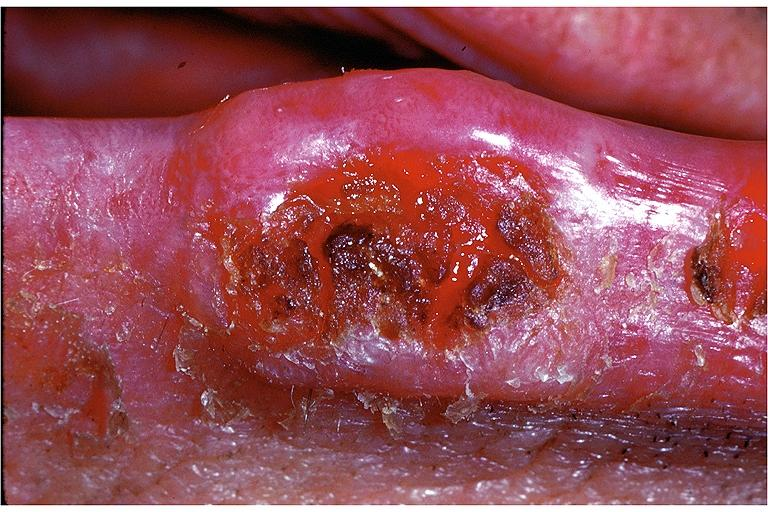s malformed base present?
Answer the question using a single word or phrase. No 